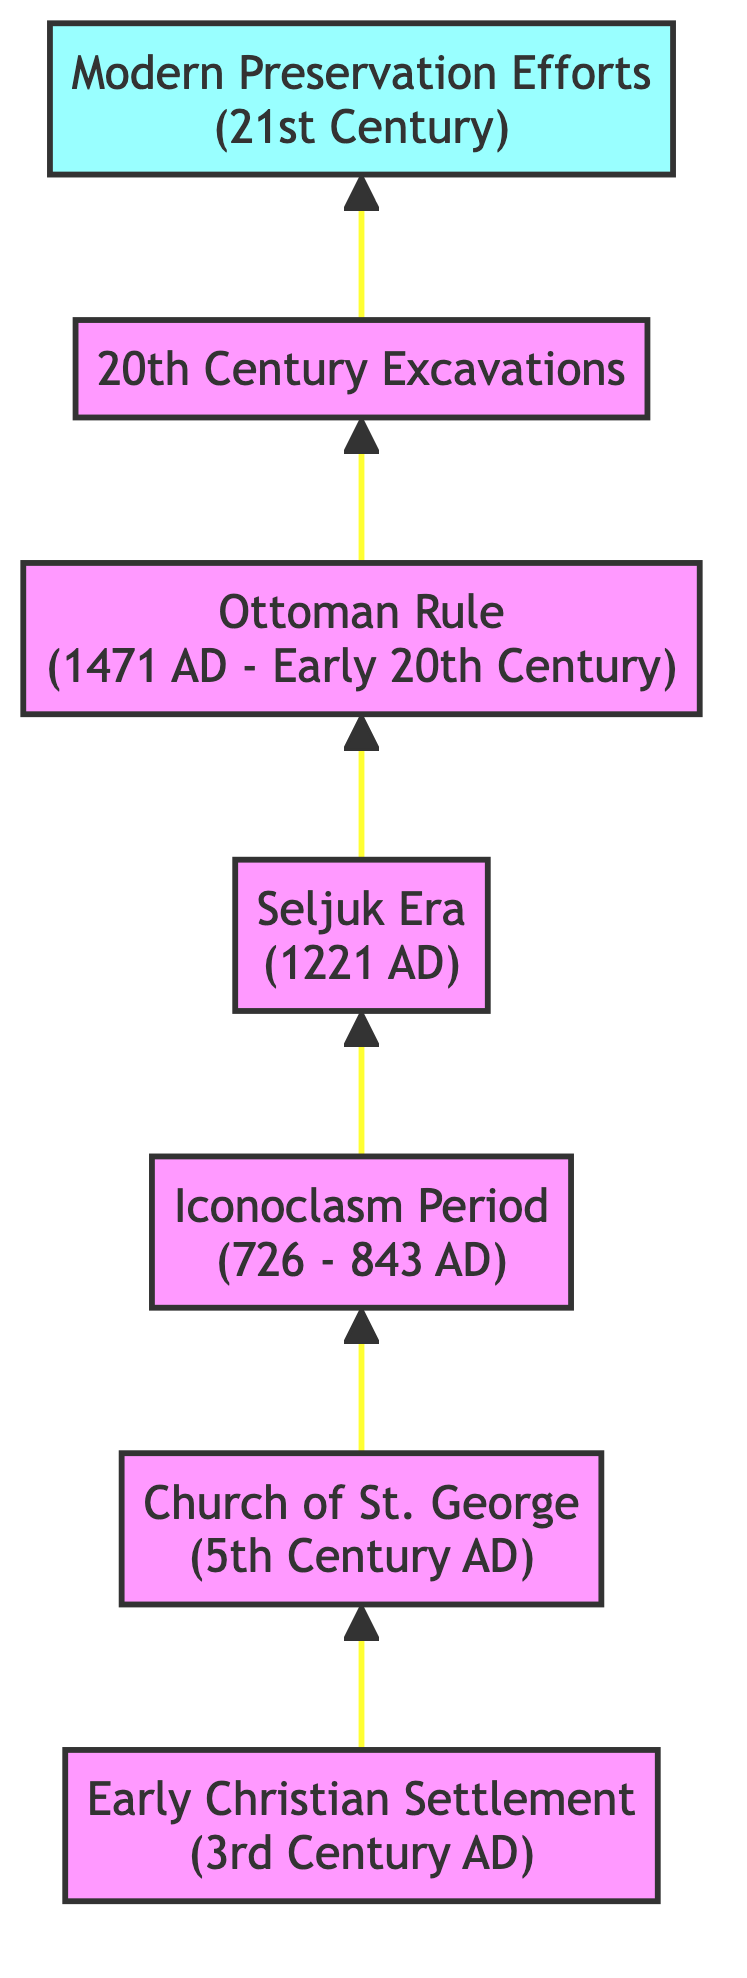What is the earliest event in the timeline? The diagram starts with the earliest event, which is the "Early Christian Settlement" from the 3rd Century AD. Therefore, the first node provides this information clearly.
Answer: Early Christian Settlement (3rd Century AD) How many preservation milestones are listed in the diagram? By counting the nodes in the diagram, there are a total of seven milestones. Each element represents a significant point in the historical timeline regarding Christian artifacts in Alanya.
Answer: 7 What century marks the construction of the Church of St. George? The node representing the "Church of St. George" states that it was constructed in the "5th Century AD." Hence, the information is directly available in the diagram.
Answer: 5th Century AD Which event directly follows the Iconoclasm Period? According to the diagram's flow, after the "Iconoclasm Period," the next event in sequence is the "Seljuk Era." The upward flow of the chart indicates this order.
Answer: Seljuk Era (1221 AD) During which period were significant archaeological excavations conducted? The diagram shows "20th Century Excavations" as a distinct milestone, directly indicating that archaeological efforts began during that time.
Answer: 20th Century What event led to the preservation and transformation of Christian sites? The "Seljuk Era" event leads to the conclusion that during this era, many Christian sites were preserved and adapted for new uses, based on the information provided in the flow of the diagram.
Answer: Seljuk Era (1221 AD) Which event occurred in the 21st Century? The diagram identifies "Modern Preservation Efforts" as the event occurring in the 21st Century, which relates specifically to the preservation of artifacts.
Answer: Modern Preservation Efforts (21st Century) 